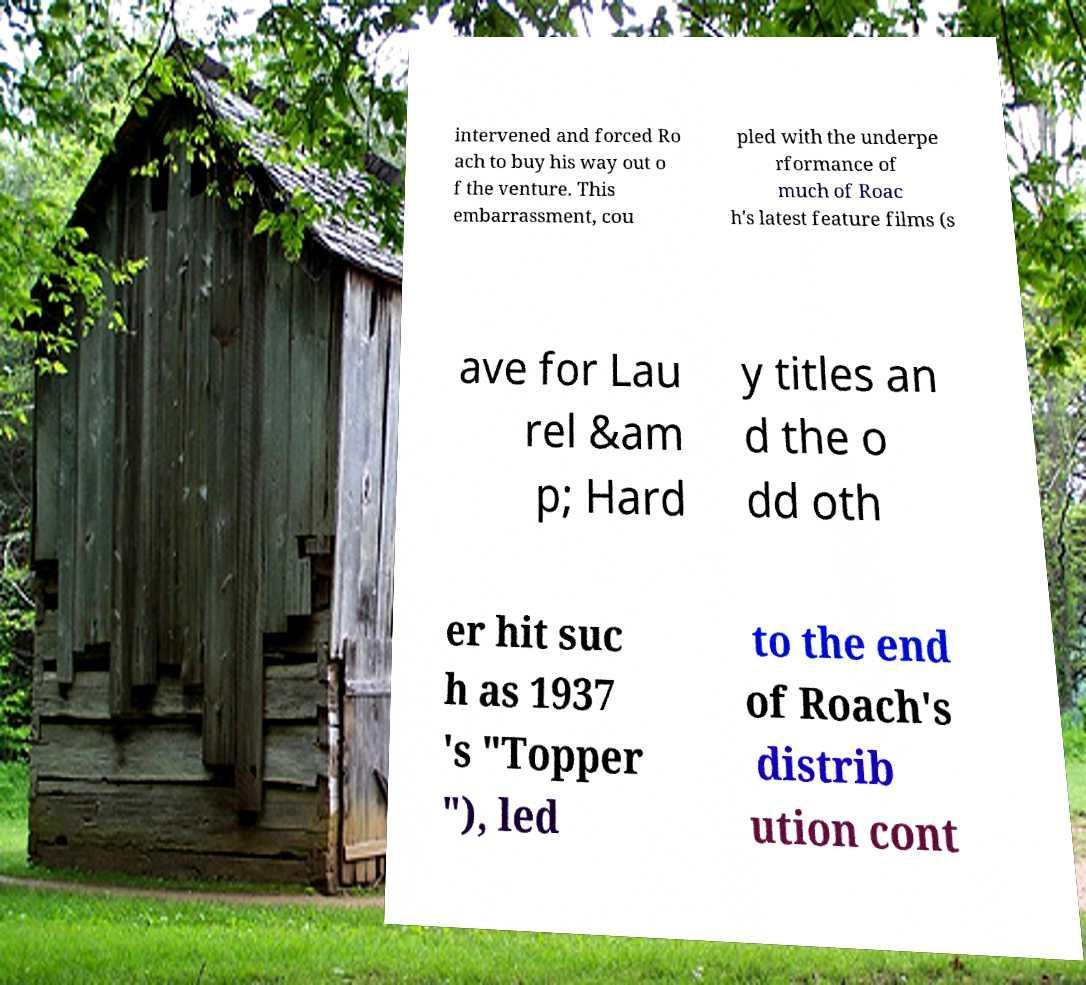For documentation purposes, I need the text within this image transcribed. Could you provide that? intervened and forced Ro ach to buy his way out o f the venture. This embarrassment, cou pled with the underpe rformance of much of Roac h's latest feature films (s ave for Lau rel &am p; Hard y titles an d the o dd oth er hit suc h as 1937 's "Topper "), led to the end of Roach's distrib ution cont 